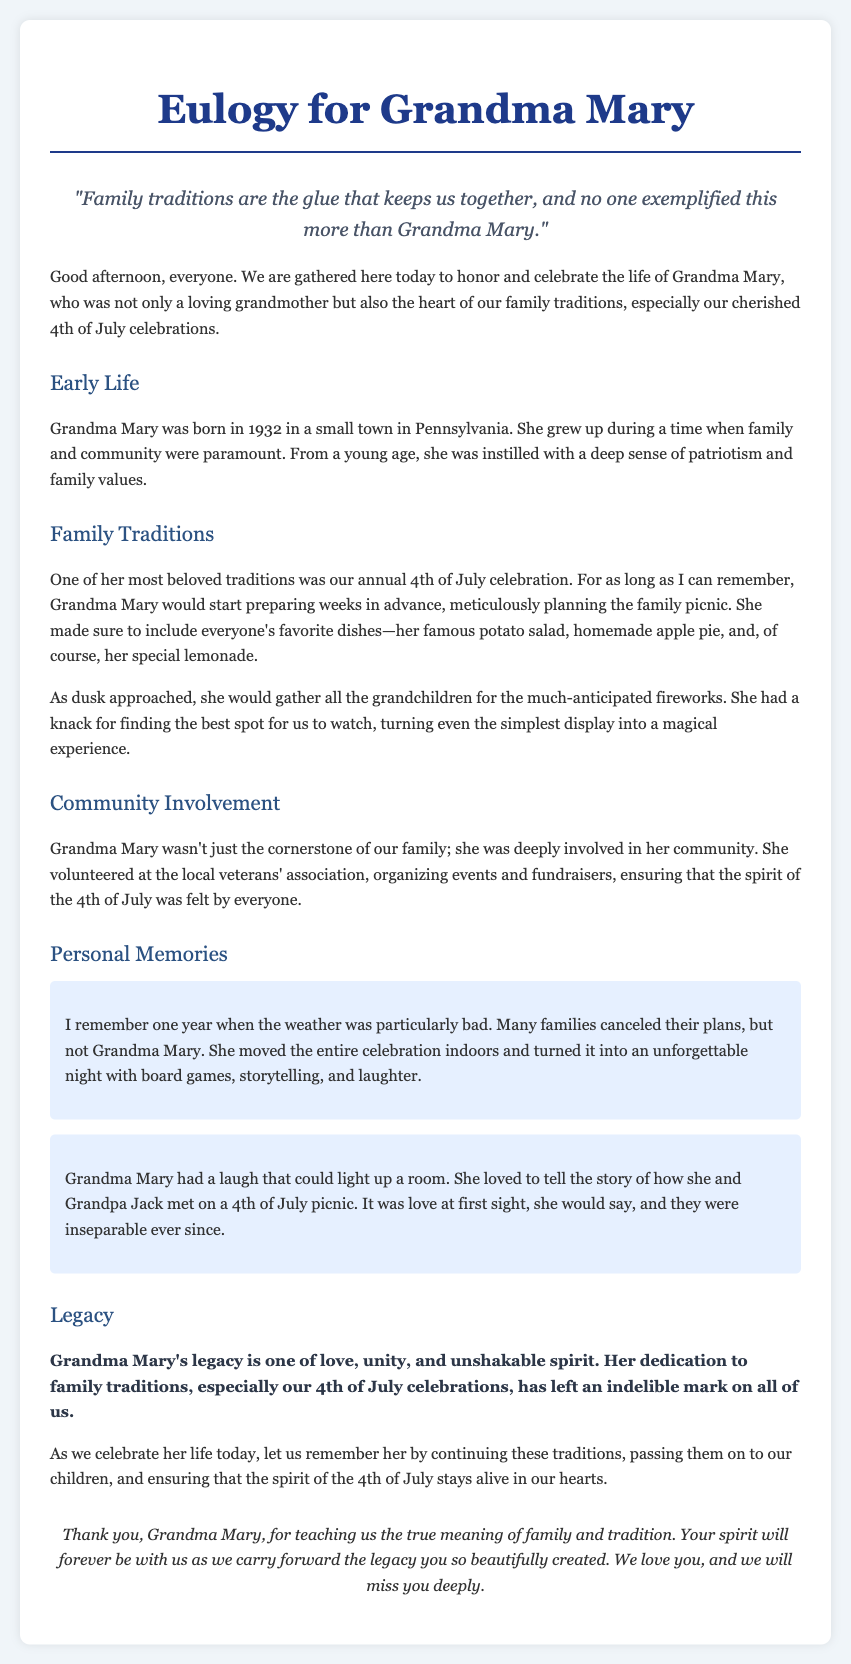What year was Grandma Mary born? Grandma Mary was born in 1932, which is stated in the Early Life section of the document.
Answer: 1932 What was Grandma Mary's famous dish for the 4th of July? The document mentions her famous potato salad as part of the family tradition during the 4th of July celebration.
Answer: Potato salad What community organization did Grandma Mary volunteer for? The document indicates that Grandma Mary volunteered at the local veterans' association, demonstrating her community involvement.
Answer: Veterans' association What did Grandma Mary do when the weather was bad during the 4th of July? The document describes how Grandma Mary moved the celebration indoors and turned it into a night of board games and storytelling due to bad weather.
Answer: Moved the celebration indoors What does Grandma Mary’s legacy represent? The document highlights that Grandma Mary's legacy is one of love, unity, and unshakable spirit, emphasizing the values she imparted to the family.
Answer: Love, unity, spirit How did Grandma Mary meet Grandpa Jack? According to the document, Grandma Mary met Grandpa Jack on a 4th of July picnic, which she often recounted.
Answer: 4th of July picnic 